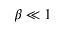<formula> <loc_0><loc_0><loc_500><loc_500>\beta \ll 1</formula> 